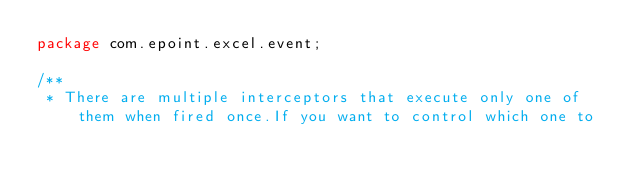Convert code to text. <code><loc_0><loc_0><loc_500><loc_500><_Java_>package com.epoint.excel.event;

/**
 * There are multiple interceptors that execute only one of them when fired once.If you want to control which one to</code> 